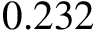<formula> <loc_0><loc_0><loc_500><loc_500>0 . 2 3 2</formula> 